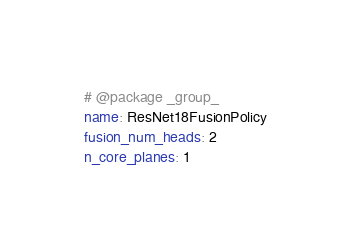Convert code to text. <code><loc_0><loc_0><loc_500><loc_500><_YAML_># @package _group_
name: ResNet18FusionPolicy
fusion_num_heads: 2
n_core_planes: 1
</code> 